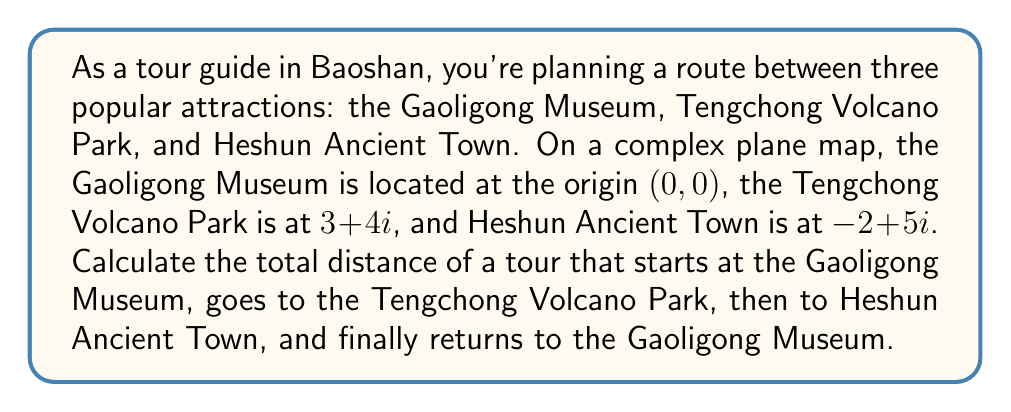Help me with this question. To solve this problem, we need to calculate the distances between each pair of locations and sum them up. We can use the distance formula in the complex plane, which is equivalent to finding the absolute value (or modulus) of the difference between two complex numbers.

1. Distance from Gaoligong Museum (0,0) to Tengchong Volcano Park (3+4i):
   $$|z_1 - z_0| = |(3+4i) - 0| = |3+4i| = \sqrt{3^2 + 4^2} = \sqrt{9 + 16} = \sqrt{25} = 5$$

2. Distance from Tengchong Volcano Park (3+4i) to Heshun Ancient Town (-2+5i):
   $$|z_2 - z_1| = |(-2+5i) - (3+4i)| = |(-5+i)| = \sqrt{(-5)^2 + 1^2} = \sqrt{25 + 1} = \sqrt{26}$$

3. Distance from Heshun Ancient Town (-2+5i) back to Gaoligong Museum (0,0):
   $$|z_0 - z_2| = |0 - (-2+5i)| = |2-5i| = \sqrt{2^2 + (-5)^2} = \sqrt{4 + 25} = \sqrt{29}$$

Now, we sum up all these distances:

$$\text{Total Distance} = 5 + \sqrt{26} + \sqrt{29}$$
Answer: The total distance of the tour is $5 + \sqrt{26} + \sqrt{29}$ units. 